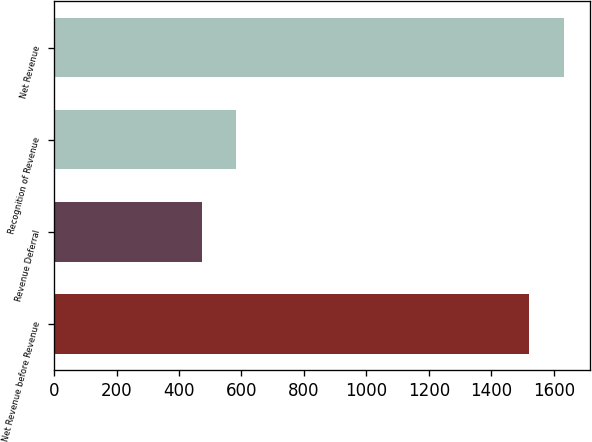Convert chart to OTSL. <chart><loc_0><loc_0><loc_500><loc_500><bar_chart><fcel>Net Revenue before Revenue<fcel>Revenue Deferral<fcel>Recognition of Revenue<fcel>Net Revenue<nl><fcel>1521<fcel>472<fcel>583.7<fcel>1632.7<nl></chart> 